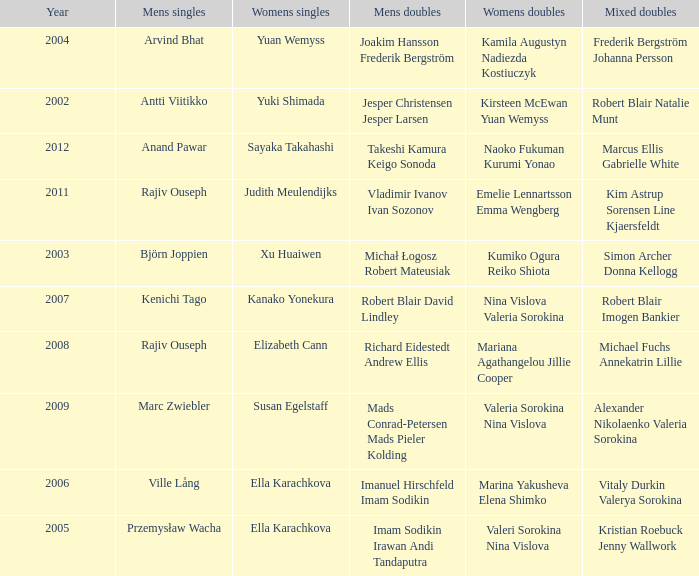Name the men's singles of marina yakusheva elena shimko Ville Lång. 